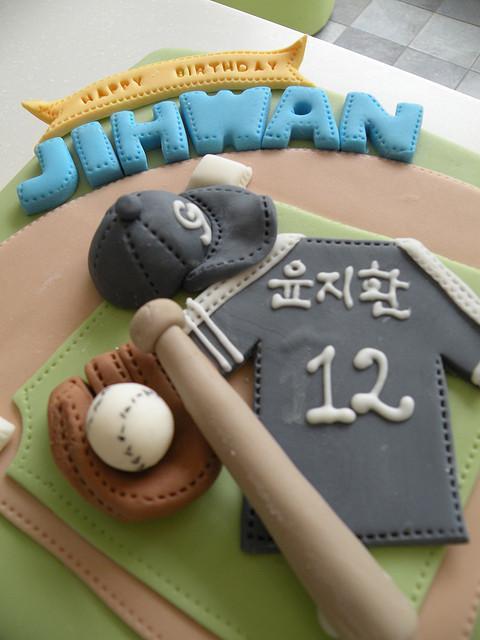How many balls in the picture?
Give a very brief answer. 1. How many baseball bats are there?
Give a very brief answer. 1. 